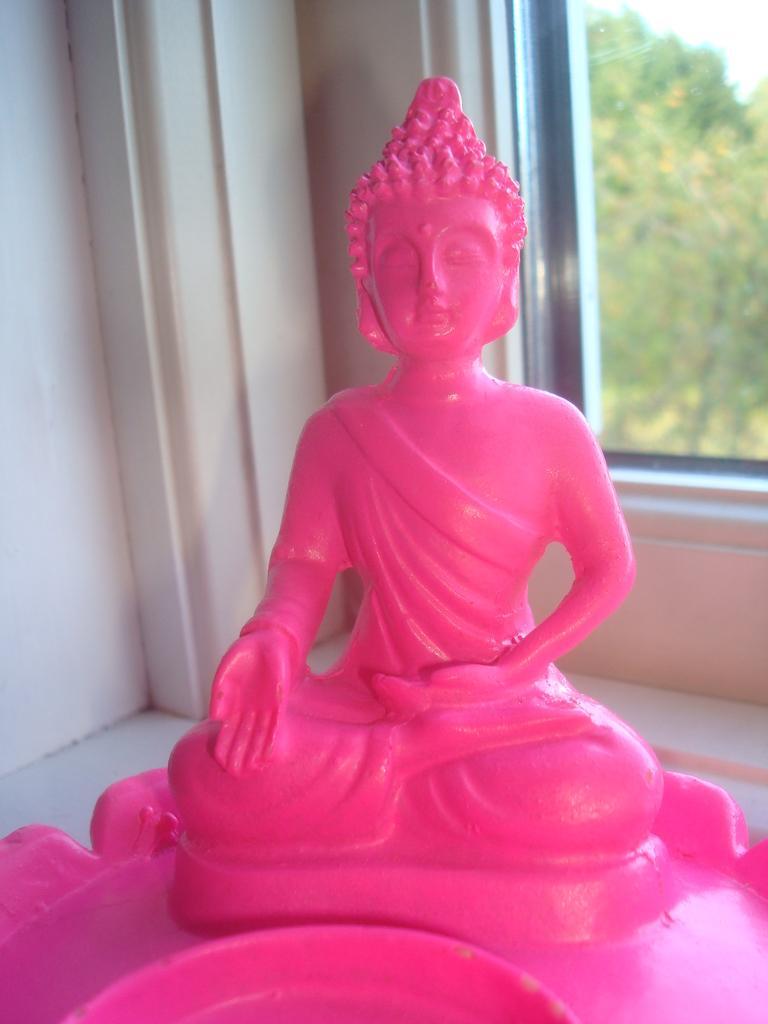Describe this image in one or two sentences. In this image I can see a statue of a Buddha which is in pink color. Background I can see the wall in white color and I can also see a window, trees in green color and the sky is in white color. 